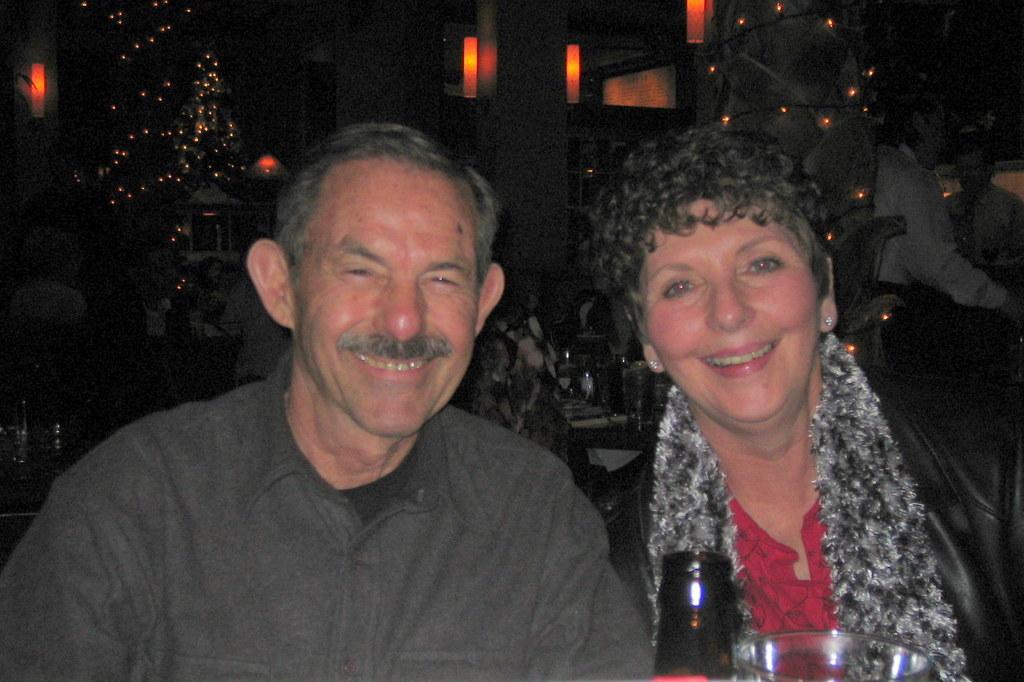In one or two sentences, can you explain what this image depicts? There are two people smiling,in front of these people we can see bottle and glass. Background it is dark and we can see people and lights. 